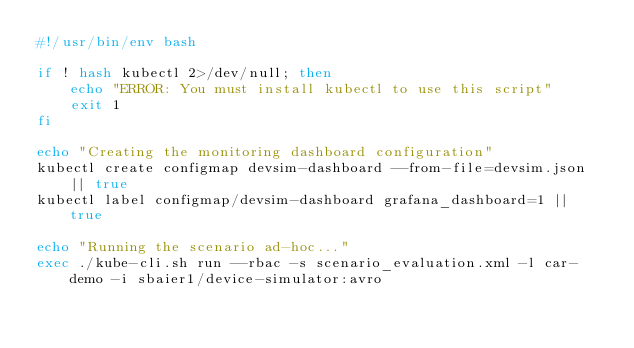<code> <loc_0><loc_0><loc_500><loc_500><_Bash_>#!/usr/bin/env bash

if ! hash kubectl 2>/dev/null; then
    echo "ERROR: You must install kubectl to use this script"
    exit 1
fi

echo "Creating the monitoring dashboard configuration"
kubectl create configmap devsim-dashboard --from-file=devsim.json || true
kubectl label configmap/devsim-dashboard grafana_dashboard=1 || true

echo "Running the scenario ad-hoc..."
exec ./kube-cli.sh run --rbac -s scenario_evaluation.xml -l car-demo -i sbaier1/device-simulator:avro</code> 